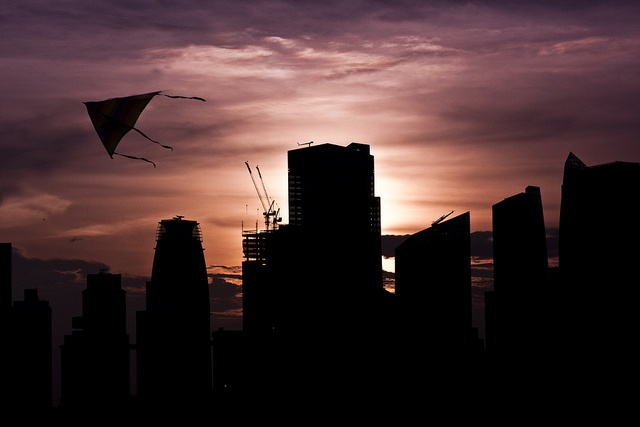Describe the objects in this image and their specific colors. I can see a kite in purple, black, brown, and maroon tones in this image. 